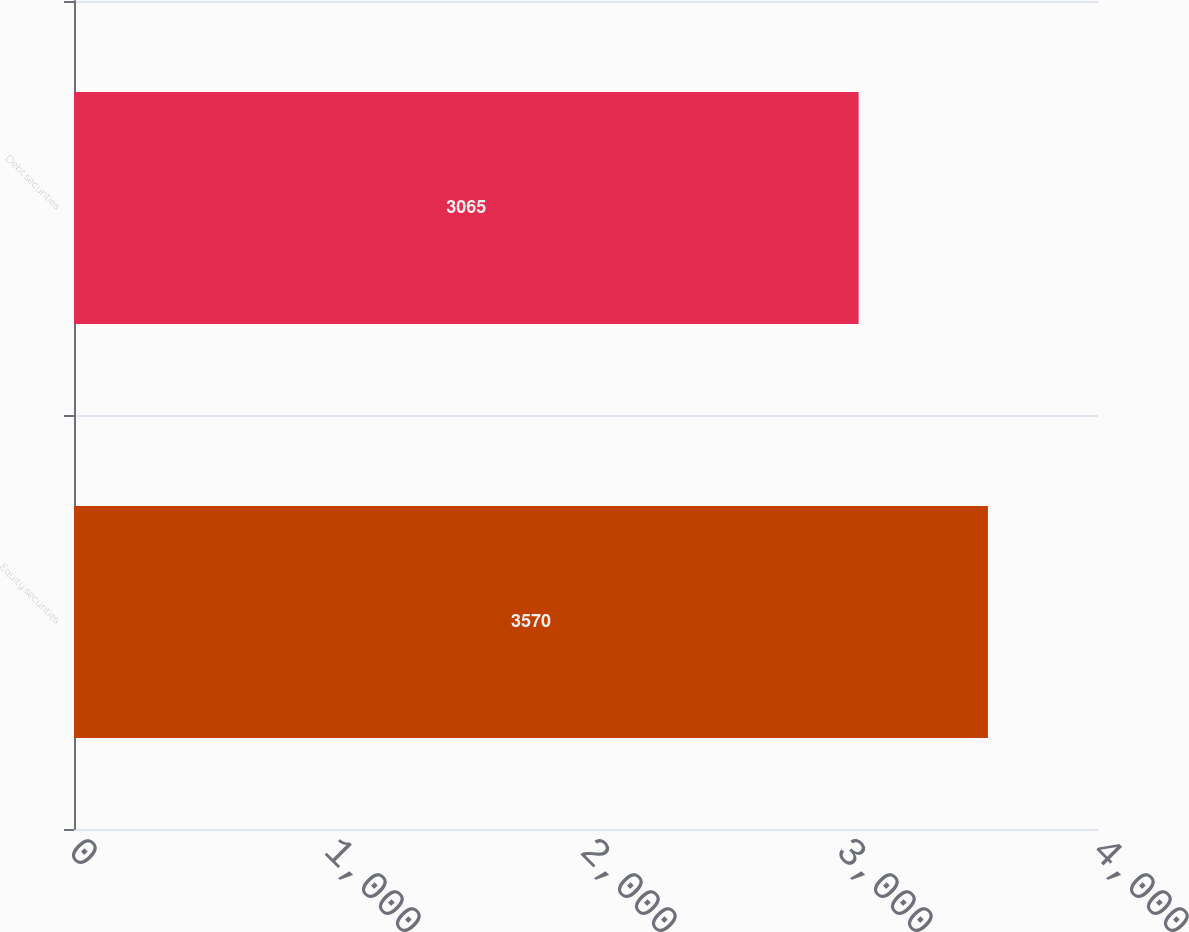Convert chart to OTSL. <chart><loc_0><loc_0><loc_500><loc_500><bar_chart><fcel>Equity securities<fcel>Debt securities<nl><fcel>3570<fcel>3065<nl></chart> 